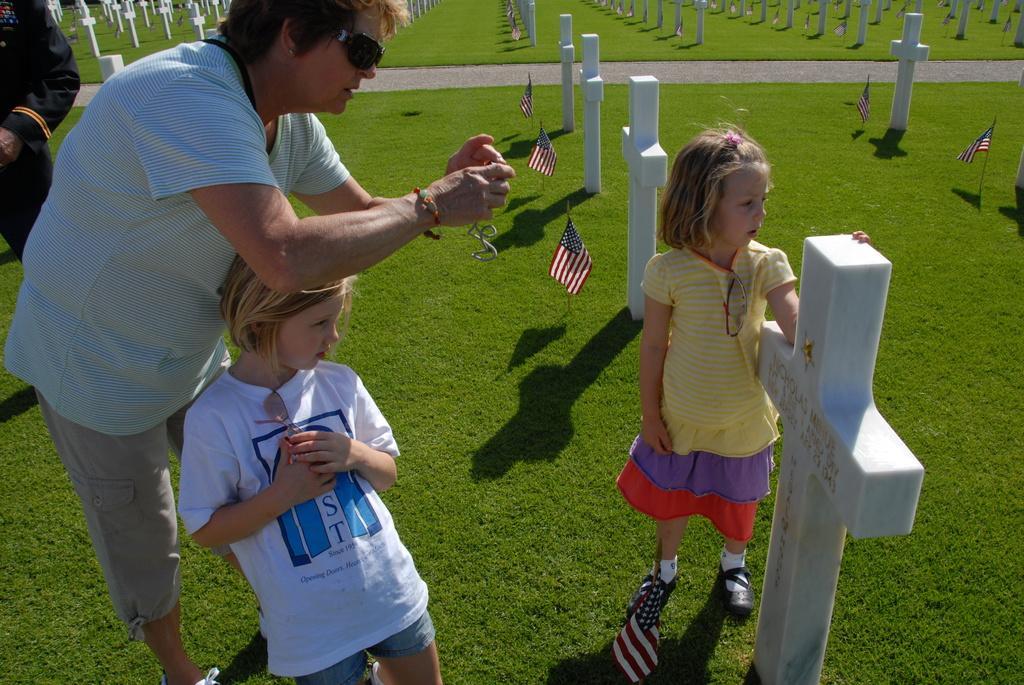Please provide a concise description of this image. In this image, we can see a graveyard. There are two kids standing and wearing clothes. There are flags in the middle of the image. There are two persons wearing clothes. 